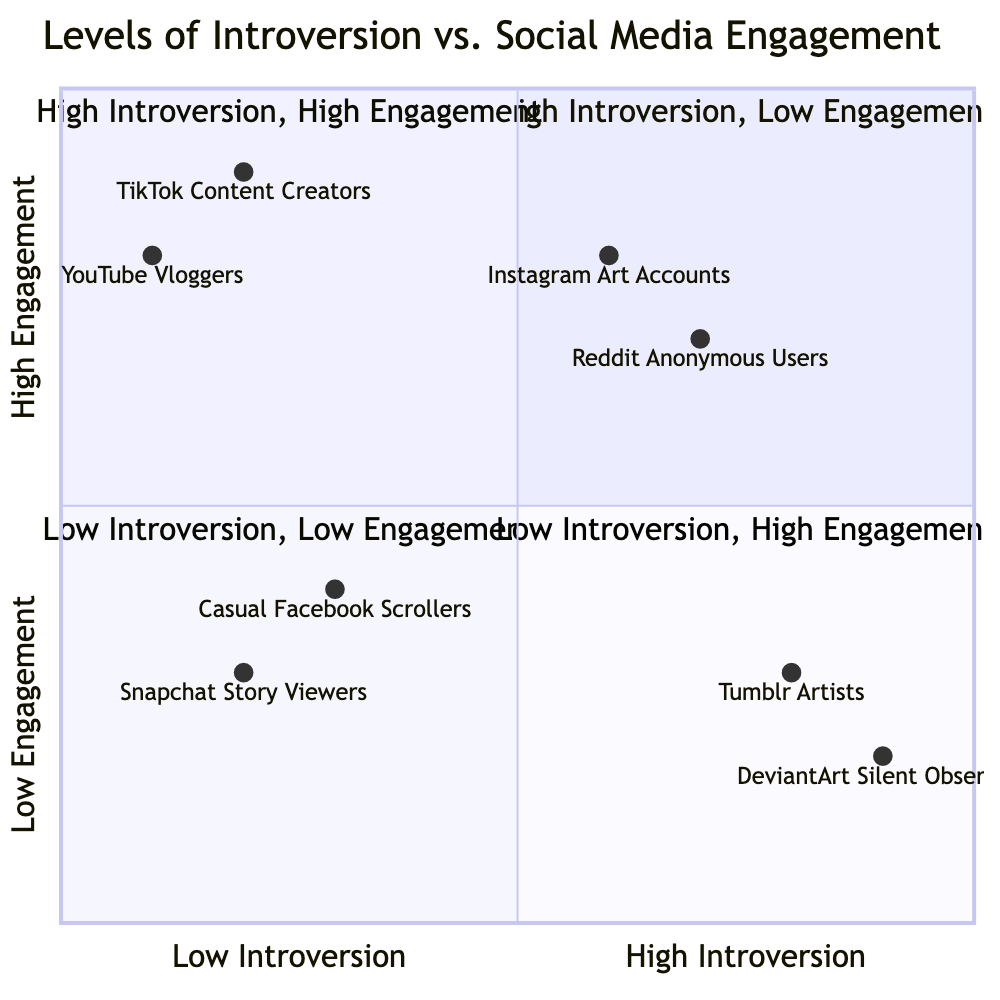What examples are found in the High Introversion, Low Engagement quadrant? The High Introversion, Low Engagement quadrant is labeled "High Introversion, Low Engagement." The examples listed in this quadrant are "Tumblr Artists" and "DeviantArt Silent Observers."
Answer: Tumblr Artists, DeviantArt Silent Observers How many examples are in the Low Introversion, Low Engagement quadrant? The Low Introversion, Low Engagement quadrant is labeled "Low Introversion, Low Engagement." There are two examples present in this quadrant: "Casual Facebook Scrollers" and "Snapchat Story Viewers."
Answer: 2 Which quadrant contains YouTube Vloggers? The YouTube Vloggers example is located in the Low Introversion, High Engagement quadrant, labeled "Low Introversion, High Engagement."
Answer: Low Introversion, High Engagement What is the engagement level of Reddit Anonymous Users? The engagement level of Reddit Anonymous Users, located in the High Introversion, High Engagement quadrant, is determined from the y-axis value, which shows the engagement level as high.
Answer: High Which examples represent high engagement among high introverts? The High Introversion, High Engagement quadrant contains two examples: "Reddit Anonymous Users" and "Instagram Art Accounts." Both of these represent high engagement levels among high introverts.
Answer: Reddit Anonymous Users, Instagram Art Accounts Do Casual Facebook Scrollers show high engagement? Casual Facebook Scrollers are found in the Low Introversion, Low Engagement quadrant, which indicates they show low engagement levels based on the quadrant’s labeling.
Answer: No What is the social media engagement level of TikTok Content Creators? The y-value for TikTok Content Creators indicates their social media engagement level, which can be found in the Low Introversion, High Engagement quadrant, represented as high by the quadrant.
Answer: High How does the engagement of DeviantArt Silent Observers compare to that of Snapchat Story Viewers? DeviantArt Silent Observers are placed in the High Introversion, Low Engagement quadrant, while Snapchat Story Viewers are in the Low Introversion, Low Engagement quadrant, indicating that both have low engagement, but Snapchat Story Viewers are categorized as low introversion.
Answer: Similar engagement (both low) 